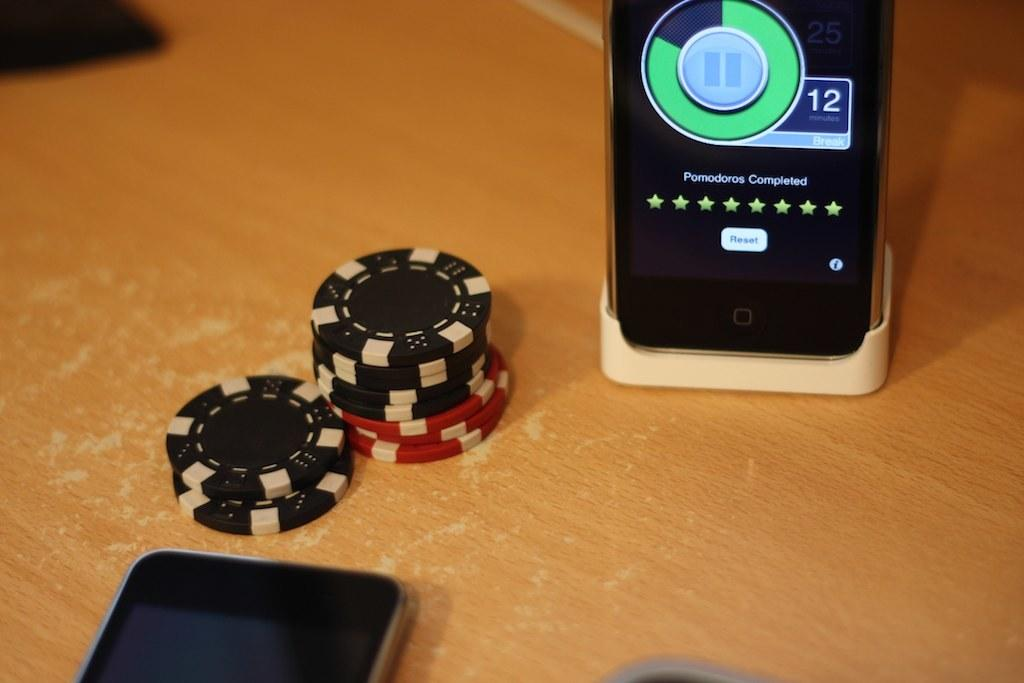<image>
Render a clear and concise summary of the photo. A phone shows a notification that Pomodoros completed is on a table along with some chips and a phone. 